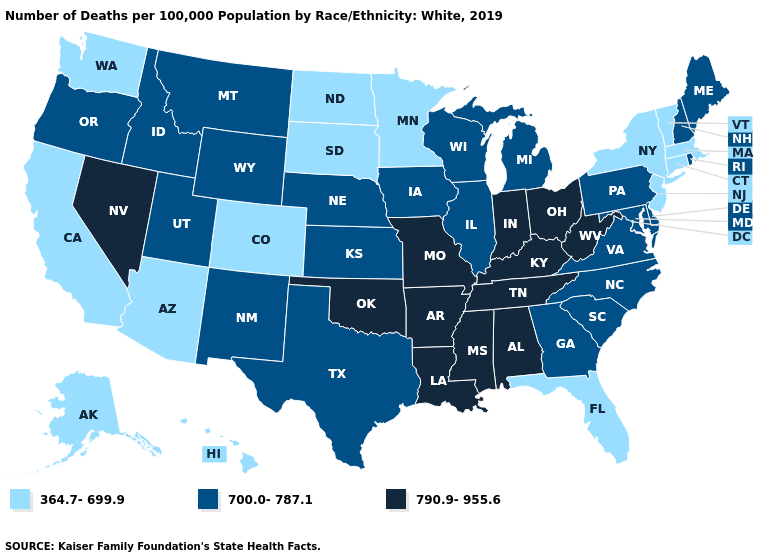Does Washington have the highest value in the USA?
Concise answer only. No. Among the states that border Wisconsin , which have the lowest value?
Write a very short answer. Minnesota. Does South Carolina have the same value as Oregon?
Give a very brief answer. Yes. Does New Hampshire have a lower value than Arizona?
Answer briefly. No. What is the highest value in the MidWest ?
Write a very short answer. 790.9-955.6. What is the value of Texas?
Concise answer only. 700.0-787.1. What is the highest value in the USA?
Quick response, please. 790.9-955.6. Does the map have missing data?
Be succinct. No. Which states hav the highest value in the South?
Write a very short answer. Alabama, Arkansas, Kentucky, Louisiana, Mississippi, Oklahoma, Tennessee, West Virginia. Is the legend a continuous bar?
Short answer required. No. Which states have the highest value in the USA?
Be succinct. Alabama, Arkansas, Indiana, Kentucky, Louisiana, Mississippi, Missouri, Nevada, Ohio, Oklahoma, Tennessee, West Virginia. What is the value of Indiana?
Answer briefly. 790.9-955.6. Among the states that border Pennsylvania , which have the highest value?
Short answer required. Ohio, West Virginia. Does Minnesota have the highest value in the MidWest?
Give a very brief answer. No. Which states have the lowest value in the MidWest?
Be succinct. Minnesota, North Dakota, South Dakota. 